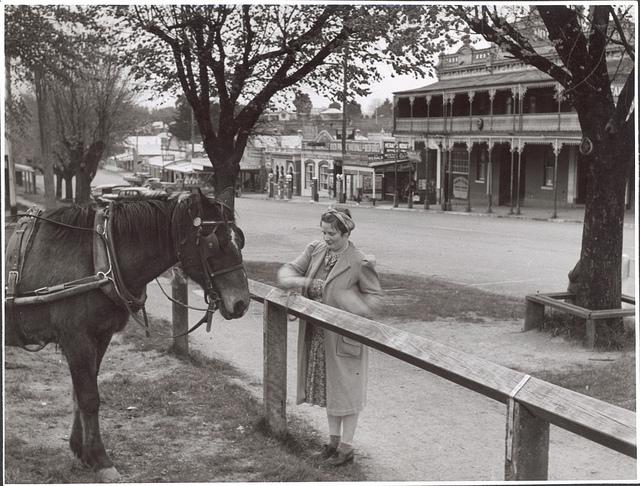What color is the horse on the left?
Quick response, please. Brown. What year was this picture taken?
Concise answer only. 1910. Is the horse at the ocean?
Concise answer only. No. What is the horse strapped to?
Answer briefly. Fence. Is this picture in color?
Write a very short answer. No. 